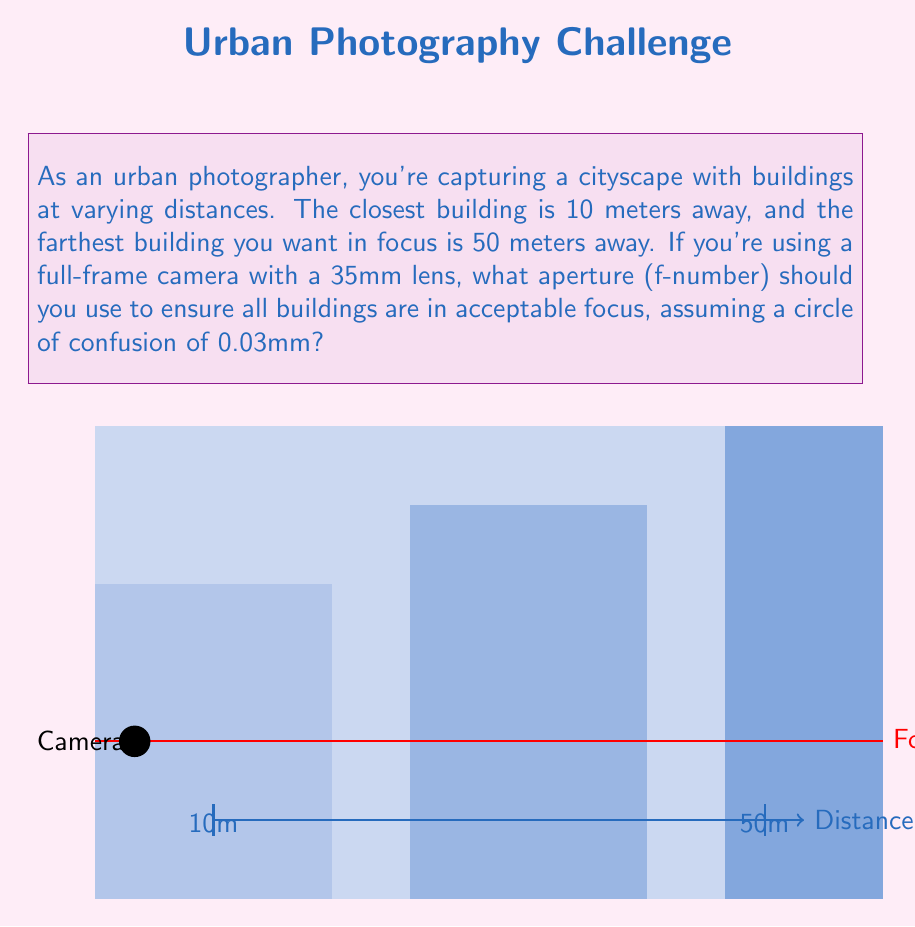Show me your answer to this math problem. To solve this problem, we'll use the hyperfocal distance formula and the depth of field equations. Let's break it down step-by-step:

1) First, we need to calculate the hyperfocal distance (H). The formula for hyperfocal distance is:

   $$H = \frac{f^2}{N \cdot c} + f$$

   Where:
   $f$ = focal length (35mm)
   $N$ = aperture (f-number, unknown)
   $c$ = circle of confusion (0.03mm)

2) Next, we use the depth of field equations:

   Near limit: $$D_n = \frac{H \cdot s}{H + (s - f)}$$
   Far limit: $$D_f = \frac{H \cdot s}{H - (s - f)}$$

   Where:
   $D_n$ = near limit of acceptable sharpness (10,000mm)
   $D_f$ = far limit of acceptable sharpness (50,000mm)
   $s$ = focus distance (unknown)

3) We can rearrange the near limit equation to solve for H:

   $$H = \frac{D_n \cdot (s - f)}{s - D_n}$$

4) Substitute this into the far limit equation:

   $$50000 = \frac{\frac{D_n \cdot (s - f)}{s - D_n} \cdot s}{\frac{D_n \cdot (s - f)}{s - D_n} - (s - f)}$$

5) Simplify and solve for s:

   $$s \approx 16666.67 \text{ mm}$$

6) Now we can calculate H:

   $$H \approx 33333.33 \text{ mm}$$

7) Finally, we can use the hyperfocal distance formula to solve for N:

   $$33333.33 = \frac{35^2}{N \cdot 0.03} + 35$$

   $$N \approx 8.75$$

8) Round up to the nearest standard f-stop:

   $$N = f/11$$
Answer: f/11 